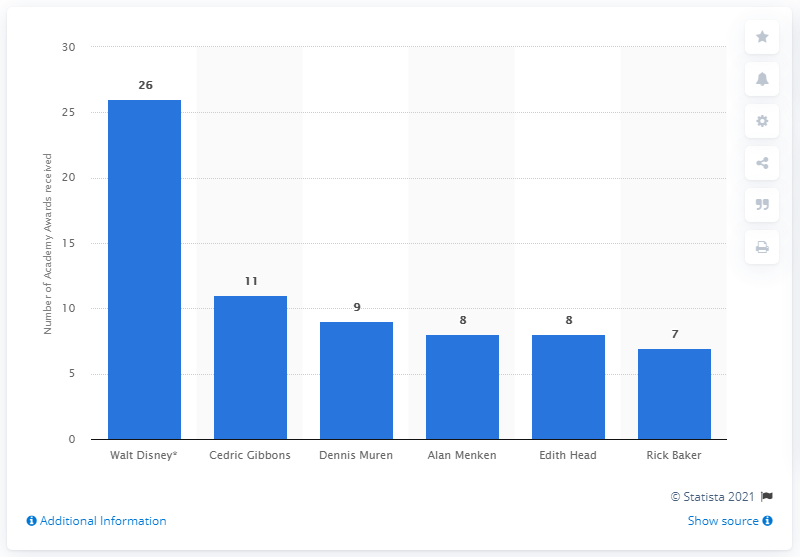Draw attention to some important aspects in this diagram. Cedric Gibbons was awarded the Oscar 11 times. Cedric Gibbons designed the Oscar statuette 11 times, making him the most prolific designer of the award. Walt Disney won the Academy Award 26 times. 